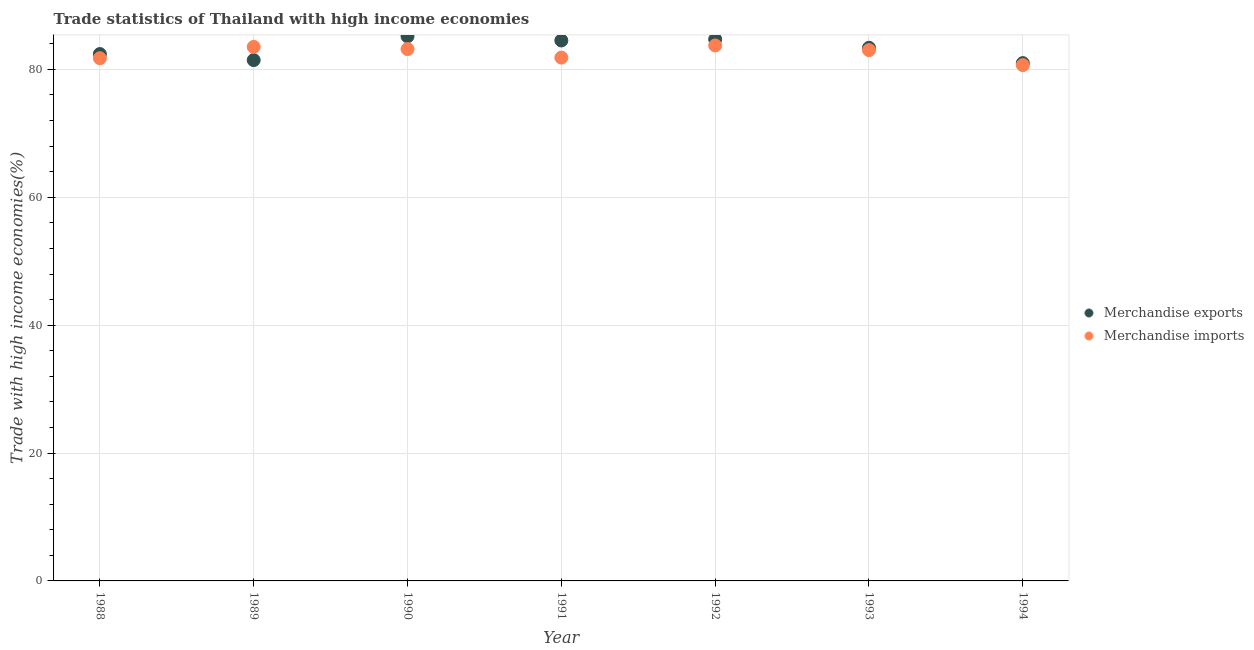Is the number of dotlines equal to the number of legend labels?
Provide a short and direct response. Yes. What is the merchandise imports in 1993?
Offer a very short reply. 83.02. Across all years, what is the maximum merchandise imports?
Make the answer very short. 83.75. Across all years, what is the minimum merchandise exports?
Ensure brevity in your answer.  80.99. In which year was the merchandise imports minimum?
Offer a terse response. 1994. What is the total merchandise imports in the graph?
Provide a short and direct response. 577.76. What is the difference between the merchandise imports in 1990 and that in 1992?
Provide a short and direct response. -0.56. What is the difference between the merchandise exports in 1989 and the merchandise imports in 1993?
Your answer should be very brief. -1.56. What is the average merchandise imports per year?
Your response must be concise. 82.54. In the year 1993, what is the difference between the merchandise imports and merchandise exports?
Provide a short and direct response. -0.37. In how many years, is the merchandise imports greater than 44 %?
Give a very brief answer. 7. What is the ratio of the merchandise exports in 1989 to that in 1991?
Make the answer very short. 0.96. Is the merchandise imports in 1993 less than that in 1994?
Give a very brief answer. No. What is the difference between the highest and the second highest merchandise imports?
Your response must be concise. 0.23. What is the difference between the highest and the lowest merchandise imports?
Your answer should be compact. 3.07. In how many years, is the merchandise exports greater than the average merchandise exports taken over all years?
Make the answer very short. 4. Does the merchandise imports monotonically increase over the years?
Your response must be concise. No. Is the merchandise exports strictly greater than the merchandise imports over the years?
Keep it short and to the point. No. Is the merchandise imports strictly less than the merchandise exports over the years?
Give a very brief answer. No. How many dotlines are there?
Your answer should be compact. 2. What is the difference between two consecutive major ticks on the Y-axis?
Offer a very short reply. 20. Does the graph contain any zero values?
Provide a short and direct response. No. What is the title of the graph?
Give a very brief answer. Trade statistics of Thailand with high income economies. Does "Primary education" appear as one of the legend labels in the graph?
Your answer should be very brief. No. What is the label or title of the Y-axis?
Offer a very short reply. Trade with high income economies(%). What is the Trade with high income economies(%) of Merchandise exports in 1988?
Your answer should be compact. 82.4. What is the Trade with high income economies(%) of Merchandise imports in 1988?
Your answer should be compact. 81.75. What is the Trade with high income economies(%) in Merchandise exports in 1989?
Offer a very short reply. 81.46. What is the Trade with high income economies(%) in Merchandise imports in 1989?
Your response must be concise. 83.52. What is the Trade with high income economies(%) of Merchandise exports in 1990?
Ensure brevity in your answer.  85.18. What is the Trade with high income economies(%) in Merchandise imports in 1990?
Provide a short and direct response. 83.19. What is the Trade with high income economies(%) of Merchandise exports in 1991?
Provide a succinct answer. 84.53. What is the Trade with high income economies(%) of Merchandise imports in 1991?
Offer a terse response. 81.85. What is the Trade with high income economies(%) in Merchandise exports in 1992?
Your answer should be compact. 84.72. What is the Trade with high income economies(%) of Merchandise imports in 1992?
Ensure brevity in your answer.  83.75. What is the Trade with high income economies(%) of Merchandise exports in 1993?
Offer a very short reply. 83.39. What is the Trade with high income economies(%) in Merchandise imports in 1993?
Offer a terse response. 83.02. What is the Trade with high income economies(%) in Merchandise exports in 1994?
Your answer should be very brief. 80.99. What is the Trade with high income economies(%) of Merchandise imports in 1994?
Your answer should be very brief. 80.68. Across all years, what is the maximum Trade with high income economies(%) in Merchandise exports?
Ensure brevity in your answer.  85.18. Across all years, what is the maximum Trade with high income economies(%) in Merchandise imports?
Offer a terse response. 83.75. Across all years, what is the minimum Trade with high income economies(%) of Merchandise exports?
Provide a succinct answer. 80.99. Across all years, what is the minimum Trade with high income economies(%) in Merchandise imports?
Provide a short and direct response. 80.68. What is the total Trade with high income economies(%) in Merchandise exports in the graph?
Make the answer very short. 582.66. What is the total Trade with high income economies(%) in Merchandise imports in the graph?
Keep it short and to the point. 577.76. What is the difference between the Trade with high income economies(%) in Merchandise exports in 1988 and that in 1989?
Provide a succinct answer. 0.95. What is the difference between the Trade with high income economies(%) in Merchandise imports in 1988 and that in 1989?
Offer a terse response. -1.77. What is the difference between the Trade with high income economies(%) of Merchandise exports in 1988 and that in 1990?
Your response must be concise. -2.77. What is the difference between the Trade with high income economies(%) of Merchandise imports in 1988 and that in 1990?
Your response must be concise. -1.43. What is the difference between the Trade with high income economies(%) in Merchandise exports in 1988 and that in 1991?
Provide a short and direct response. -2.12. What is the difference between the Trade with high income economies(%) in Merchandise imports in 1988 and that in 1991?
Provide a succinct answer. -0.09. What is the difference between the Trade with high income economies(%) in Merchandise exports in 1988 and that in 1992?
Provide a short and direct response. -2.31. What is the difference between the Trade with high income economies(%) of Merchandise imports in 1988 and that in 1992?
Offer a very short reply. -1.99. What is the difference between the Trade with high income economies(%) in Merchandise exports in 1988 and that in 1993?
Provide a succinct answer. -0.98. What is the difference between the Trade with high income economies(%) in Merchandise imports in 1988 and that in 1993?
Give a very brief answer. -1.27. What is the difference between the Trade with high income economies(%) of Merchandise exports in 1988 and that in 1994?
Ensure brevity in your answer.  1.42. What is the difference between the Trade with high income economies(%) in Merchandise imports in 1988 and that in 1994?
Offer a very short reply. 1.08. What is the difference between the Trade with high income economies(%) in Merchandise exports in 1989 and that in 1990?
Your answer should be very brief. -3.72. What is the difference between the Trade with high income economies(%) in Merchandise imports in 1989 and that in 1990?
Provide a short and direct response. 0.33. What is the difference between the Trade with high income economies(%) in Merchandise exports in 1989 and that in 1991?
Your answer should be very brief. -3.07. What is the difference between the Trade with high income economies(%) in Merchandise imports in 1989 and that in 1991?
Provide a short and direct response. 1.67. What is the difference between the Trade with high income economies(%) in Merchandise exports in 1989 and that in 1992?
Your answer should be compact. -3.26. What is the difference between the Trade with high income economies(%) of Merchandise imports in 1989 and that in 1992?
Offer a very short reply. -0.23. What is the difference between the Trade with high income economies(%) of Merchandise exports in 1989 and that in 1993?
Ensure brevity in your answer.  -1.93. What is the difference between the Trade with high income economies(%) in Merchandise imports in 1989 and that in 1993?
Ensure brevity in your answer.  0.5. What is the difference between the Trade with high income economies(%) in Merchandise exports in 1989 and that in 1994?
Keep it short and to the point. 0.47. What is the difference between the Trade with high income economies(%) in Merchandise imports in 1989 and that in 1994?
Keep it short and to the point. 2.85. What is the difference between the Trade with high income economies(%) in Merchandise exports in 1990 and that in 1991?
Give a very brief answer. 0.65. What is the difference between the Trade with high income economies(%) of Merchandise imports in 1990 and that in 1991?
Your answer should be very brief. 1.34. What is the difference between the Trade with high income economies(%) of Merchandise exports in 1990 and that in 1992?
Keep it short and to the point. 0.46. What is the difference between the Trade with high income economies(%) of Merchandise imports in 1990 and that in 1992?
Your answer should be compact. -0.56. What is the difference between the Trade with high income economies(%) of Merchandise exports in 1990 and that in 1993?
Your answer should be very brief. 1.79. What is the difference between the Trade with high income economies(%) of Merchandise imports in 1990 and that in 1993?
Give a very brief answer. 0.17. What is the difference between the Trade with high income economies(%) in Merchandise exports in 1990 and that in 1994?
Offer a terse response. 4.19. What is the difference between the Trade with high income economies(%) in Merchandise imports in 1990 and that in 1994?
Your answer should be compact. 2.51. What is the difference between the Trade with high income economies(%) of Merchandise exports in 1991 and that in 1992?
Give a very brief answer. -0.19. What is the difference between the Trade with high income economies(%) of Merchandise imports in 1991 and that in 1992?
Make the answer very short. -1.9. What is the difference between the Trade with high income economies(%) of Merchandise exports in 1991 and that in 1993?
Ensure brevity in your answer.  1.14. What is the difference between the Trade with high income economies(%) in Merchandise imports in 1991 and that in 1993?
Make the answer very short. -1.17. What is the difference between the Trade with high income economies(%) of Merchandise exports in 1991 and that in 1994?
Offer a very short reply. 3.54. What is the difference between the Trade with high income economies(%) in Merchandise imports in 1991 and that in 1994?
Give a very brief answer. 1.17. What is the difference between the Trade with high income economies(%) of Merchandise exports in 1992 and that in 1993?
Keep it short and to the point. 1.33. What is the difference between the Trade with high income economies(%) of Merchandise imports in 1992 and that in 1993?
Keep it short and to the point. 0.73. What is the difference between the Trade with high income economies(%) of Merchandise exports in 1992 and that in 1994?
Your answer should be compact. 3.73. What is the difference between the Trade with high income economies(%) in Merchandise imports in 1992 and that in 1994?
Offer a terse response. 3.07. What is the difference between the Trade with high income economies(%) in Merchandise exports in 1993 and that in 1994?
Give a very brief answer. 2.4. What is the difference between the Trade with high income economies(%) of Merchandise imports in 1993 and that in 1994?
Ensure brevity in your answer.  2.34. What is the difference between the Trade with high income economies(%) in Merchandise exports in 1988 and the Trade with high income economies(%) in Merchandise imports in 1989?
Provide a short and direct response. -1.12. What is the difference between the Trade with high income economies(%) in Merchandise exports in 1988 and the Trade with high income economies(%) in Merchandise imports in 1990?
Your answer should be very brief. -0.79. What is the difference between the Trade with high income economies(%) of Merchandise exports in 1988 and the Trade with high income economies(%) of Merchandise imports in 1991?
Provide a succinct answer. 0.55. What is the difference between the Trade with high income economies(%) of Merchandise exports in 1988 and the Trade with high income economies(%) of Merchandise imports in 1992?
Your response must be concise. -1.34. What is the difference between the Trade with high income economies(%) of Merchandise exports in 1988 and the Trade with high income economies(%) of Merchandise imports in 1993?
Your response must be concise. -0.62. What is the difference between the Trade with high income economies(%) in Merchandise exports in 1988 and the Trade with high income economies(%) in Merchandise imports in 1994?
Your answer should be compact. 1.73. What is the difference between the Trade with high income economies(%) in Merchandise exports in 1989 and the Trade with high income economies(%) in Merchandise imports in 1990?
Offer a very short reply. -1.73. What is the difference between the Trade with high income economies(%) of Merchandise exports in 1989 and the Trade with high income economies(%) of Merchandise imports in 1991?
Your response must be concise. -0.39. What is the difference between the Trade with high income economies(%) of Merchandise exports in 1989 and the Trade with high income economies(%) of Merchandise imports in 1992?
Ensure brevity in your answer.  -2.29. What is the difference between the Trade with high income economies(%) of Merchandise exports in 1989 and the Trade with high income economies(%) of Merchandise imports in 1993?
Your answer should be very brief. -1.56. What is the difference between the Trade with high income economies(%) of Merchandise exports in 1989 and the Trade with high income economies(%) of Merchandise imports in 1994?
Provide a short and direct response. 0.78. What is the difference between the Trade with high income economies(%) of Merchandise exports in 1990 and the Trade with high income economies(%) of Merchandise imports in 1991?
Provide a succinct answer. 3.33. What is the difference between the Trade with high income economies(%) in Merchandise exports in 1990 and the Trade with high income economies(%) in Merchandise imports in 1992?
Offer a terse response. 1.43. What is the difference between the Trade with high income economies(%) of Merchandise exports in 1990 and the Trade with high income economies(%) of Merchandise imports in 1993?
Your response must be concise. 2.16. What is the difference between the Trade with high income economies(%) of Merchandise exports in 1990 and the Trade with high income economies(%) of Merchandise imports in 1994?
Provide a succinct answer. 4.5. What is the difference between the Trade with high income economies(%) in Merchandise exports in 1991 and the Trade with high income economies(%) in Merchandise imports in 1992?
Your answer should be very brief. 0.78. What is the difference between the Trade with high income economies(%) of Merchandise exports in 1991 and the Trade with high income economies(%) of Merchandise imports in 1993?
Offer a terse response. 1.51. What is the difference between the Trade with high income economies(%) in Merchandise exports in 1991 and the Trade with high income economies(%) in Merchandise imports in 1994?
Provide a succinct answer. 3.85. What is the difference between the Trade with high income economies(%) of Merchandise exports in 1992 and the Trade with high income economies(%) of Merchandise imports in 1993?
Offer a very short reply. 1.7. What is the difference between the Trade with high income economies(%) in Merchandise exports in 1992 and the Trade with high income economies(%) in Merchandise imports in 1994?
Offer a very short reply. 4.04. What is the difference between the Trade with high income economies(%) of Merchandise exports in 1993 and the Trade with high income economies(%) of Merchandise imports in 1994?
Make the answer very short. 2.71. What is the average Trade with high income economies(%) of Merchandise exports per year?
Provide a short and direct response. 83.24. What is the average Trade with high income economies(%) of Merchandise imports per year?
Offer a very short reply. 82.54. In the year 1988, what is the difference between the Trade with high income economies(%) of Merchandise exports and Trade with high income economies(%) of Merchandise imports?
Give a very brief answer. 0.65. In the year 1989, what is the difference between the Trade with high income economies(%) of Merchandise exports and Trade with high income economies(%) of Merchandise imports?
Your answer should be compact. -2.06. In the year 1990, what is the difference between the Trade with high income economies(%) of Merchandise exports and Trade with high income economies(%) of Merchandise imports?
Keep it short and to the point. 1.99. In the year 1991, what is the difference between the Trade with high income economies(%) in Merchandise exports and Trade with high income economies(%) in Merchandise imports?
Give a very brief answer. 2.68. In the year 1992, what is the difference between the Trade with high income economies(%) in Merchandise exports and Trade with high income economies(%) in Merchandise imports?
Your answer should be very brief. 0.97. In the year 1993, what is the difference between the Trade with high income economies(%) of Merchandise exports and Trade with high income economies(%) of Merchandise imports?
Your answer should be very brief. 0.37. In the year 1994, what is the difference between the Trade with high income economies(%) in Merchandise exports and Trade with high income economies(%) in Merchandise imports?
Your answer should be compact. 0.31. What is the ratio of the Trade with high income economies(%) in Merchandise exports in 1988 to that in 1989?
Provide a succinct answer. 1.01. What is the ratio of the Trade with high income economies(%) in Merchandise imports in 1988 to that in 1989?
Provide a succinct answer. 0.98. What is the ratio of the Trade with high income economies(%) in Merchandise exports in 1988 to that in 1990?
Offer a terse response. 0.97. What is the ratio of the Trade with high income economies(%) in Merchandise imports in 1988 to that in 1990?
Ensure brevity in your answer.  0.98. What is the ratio of the Trade with high income economies(%) in Merchandise exports in 1988 to that in 1991?
Ensure brevity in your answer.  0.97. What is the ratio of the Trade with high income economies(%) in Merchandise exports in 1988 to that in 1992?
Make the answer very short. 0.97. What is the ratio of the Trade with high income economies(%) of Merchandise imports in 1988 to that in 1992?
Give a very brief answer. 0.98. What is the ratio of the Trade with high income economies(%) in Merchandise exports in 1988 to that in 1994?
Your answer should be very brief. 1.02. What is the ratio of the Trade with high income economies(%) of Merchandise imports in 1988 to that in 1994?
Provide a succinct answer. 1.01. What is the ratio of the Trade with high income economies(%) of Merchandise exports in 1989 to that in 1990?
Offer a very short reply. 0.96. What is the ratio of the Trade with high income economies(%) of Merchandise imports in 1989 to that in 1990?
Make the answer very short. 1. What is the ratio of the Trade with high income economies(%) of Merchandise exports in 1989 to that in 1991?
Your answer should be very brief. 0.96. What is the ratio of the Trade with high income economies(%) in Merchandise imports in 1989 to that in 1991?
Give a very brief answer. 1.02. What is the ratio of the Trade with high income economies(%) of Merchandise exports in 1989 to that in 1992?
Ensure brevity in your answer.  0.96. What is the ratio of the Trade with high income economies(%) in Merchandise imports in 1989 to that in 1992?
Give a very brief answer. 1. What is the ratio of the Trade with high income economies(%) of Merchandise exports in 1989 to that in 1993?
Provide a short and direct response. 0.98. What is the ratio of the Trade with high income economies(%) in Merchandise exports in 1989 to that in 1994?
Your response must be concise. 1.01. What is the ratio of the Trade with high income economies(%) of Merchandise imports in 1989 to that in 1994?
Your answer should be compact. 1.04. What is the ratio of the Trade with high income economies(%) of Merchandise exports in 1990 to that in 1991?
Offer a terse response. 1.01. What is the ratio of the Trade with high income economies(%) in Merchandise imports in 1990 to that in 1991?
Offer a terse response. 1.02. What is the ratio of the Trade with high income economies(%) of Merchandise imports in 1990 to that in 1992?
Offer a terse response. 0.99. What is the ratio of the Trade with high income economies(%) in Merchandise exports in 1990 to that in 1993?
Offer a terse response. 1.02. What is the ratio of the Trade with high income economies(%) in Merchandise exports in 1990 to that in 1994?
Make the answer very short. 1.05. What is the ratio of the Trade with high income economies(%) in Merchandise imports in 1990 to that in 1994?
Provide a short and direct response. 1.03. What is the ratio of the Trade with high income economies(%) of Merchandise imports in 1991 to that in 1992?
Provide a short and direct response. 0.98. What is the ratio of the Trade with high income economies(%) in Merchandise exports in 1991 to that in 1993?
Offer a terse response. 1.01. What is the ratio of the Trade with high income economies(%) of Merchandise imports in 1991 to that in 1993?
Make the answer very short. 0.99. What is the ratio of the Trade with high income economies(%) in Merchandise exports in 1991 to that in 1994?
Provide a short and direct response. 1.04. What is the ratio of the Trade with high income economies(%) of Merchandise imports in 1991 to that in 1994?
Your answer should be compact. 1.01. What is the ratio of the Trade with high income economies(%) in Merchandise exports in 1992 to that in 1993?
Offer a very short reply. 1.02. What is the ratio of the Trade with high income economies(%) in Merchandise imports in 1992 to that in 1993?
Offer a very short reply. 1.01. What is the ratio of the Trade with high income economies(%) of Merchandise exports in 1992 to that in 1994?
Ensure brevity in your answer.  1.05. What is the ratio of the Trade with high income economies(%) of Merchandise imports in 1992 to that in 1994?
Offer a very short reply. 1.04. What is the ratio of the Trade with high income economies(%) of Merchandise exports in 1993 to that in 1994?
Give a very brief answer. 1.03. What is the ratio of the Trade with high income economies(%) of Merchandise imports in 1993 to that in 1994?
Give a very brief answer. 1.03. What is the difference between the highest and the second highest Trade with high income economies(%) in Merchandise exports?
Give a very brief answer. 0.46. What is the difference between the highest and the second highest Trade with high income economies(%) in Merchandise imports?
Make the answer very short. 0.23. What is the difference between the highest and the lowest Trade with high income economies(%) of Merchandise exports?
Make the answer very short. 4.19. What is the difference between the highest and the lowest Trade with high income economies(%) of Merchandise imports?
Your answer should be compact. 3.07. 